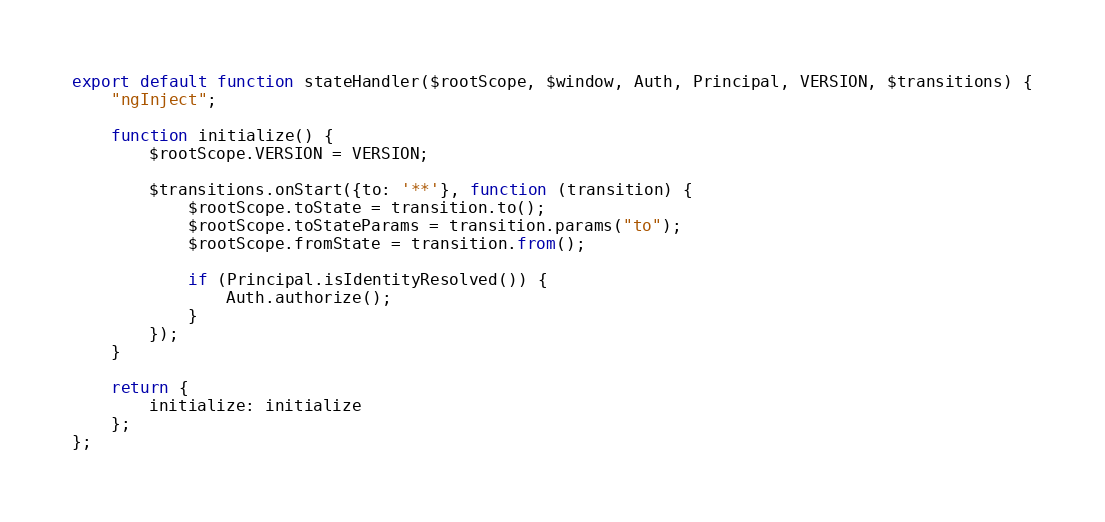Convert code to text. <code><loc_0><loc_0><loc_500><loc_500><_JavaScript_>export default function stateHandler($rootScope, $window, Auth, Principal, VERSION, $transitions) {
    "ngInject";

    function initialize() {
        $rootScope.VERSION = VERSION;

        $transitions.onStart({to: '**'}, function (transition) {
            $rootScope.toState = transition.to();
            $rootScope.toStateParams = transition.params("to");
            $rootScope.fromState = transition.from();

            if (Principal.isIdentityResolved()) {
                Auth.authorize();
            }
        });
    }

    return {
        initialize: initialize
    };
};</code> 